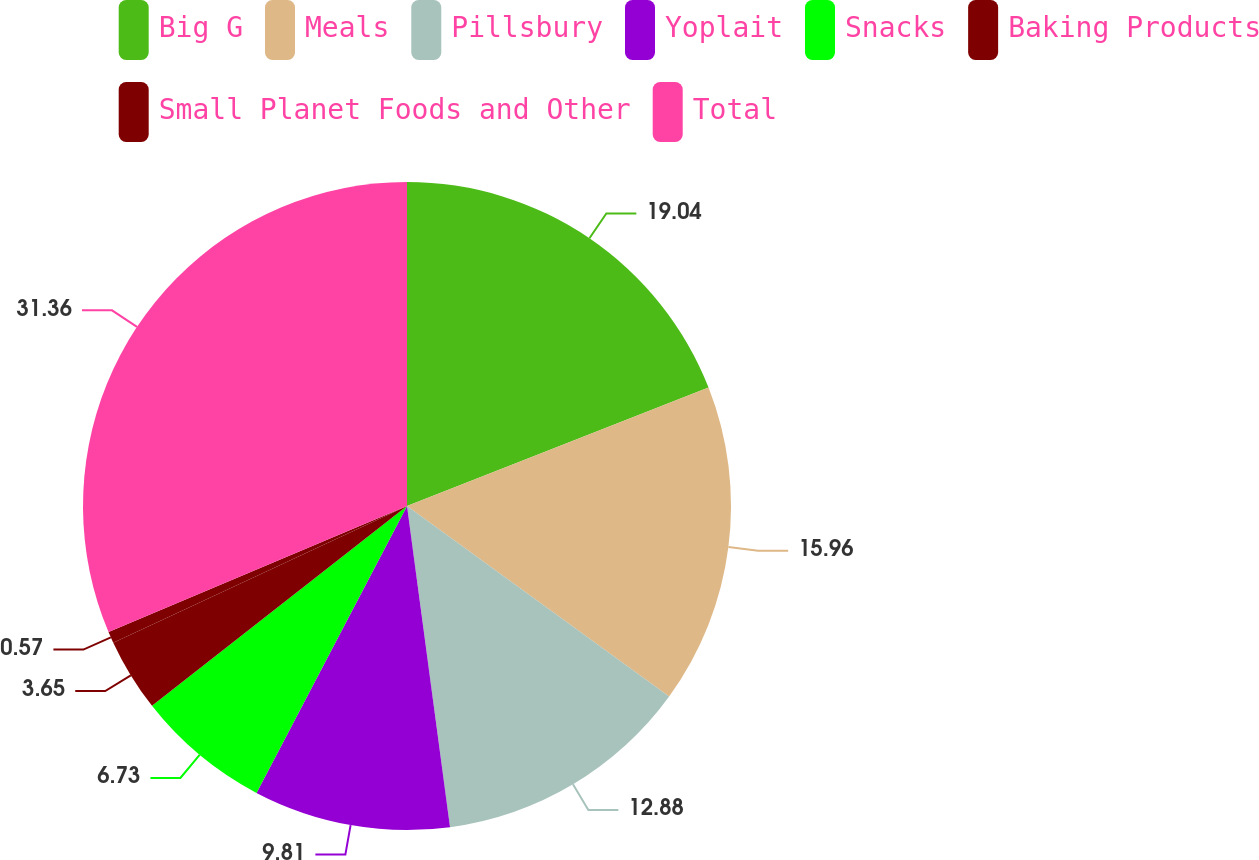Convert chart to OTSL. <chart><loc_0><loc_0><loc_500><loc_500><pie_chart><fcel>Big G<fcel>Meals<fcel>Pillsbury<fcel>Yoplait<fcel>Snacks<fcel>Baking Products<fcel>Small Planet Foods and Other<fcel>Total<nl><fcel>19.04%<fcel>15.96%<fcel>12.88%<fcel>9.81%<fcel>6.73%<fcel>3.65%<fcel>0.57%<fcel>31.36%<nl></chart> 